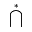<formula> <loc_0><loc_0><loc_500><loc_500>\bigcap ^ { * }</formula> 